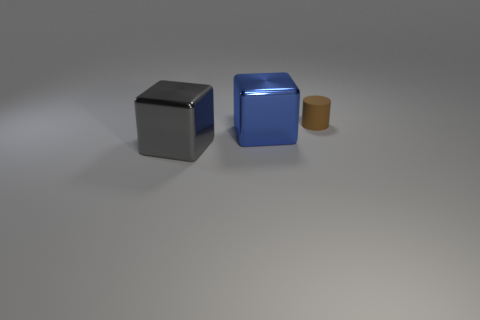What color is the large thing to the left of the cube that is behind the shiny block that is on the left side of the large blue object?
Provide a short and direct response. Gray. There is a gray object; is its size the same as the shiny cube right of the gray cube?
Offer a very short reply. Yes. How many things are either large metallic objects that are on the left side of the blue metal cube or shiny things that are to the left of the blue metal block?
Offer a very short reply. 1. There is a shiny object that is the same size as the gray metallic cube; what is its shape?
Ensure brevity in your answer.  Cube. The small brown rubber object that is behind the big metal object that is in front of the block behind the big gray metal cube is what shape?
Your answer should be very brief. Cylinder. Are there the same number of gray cubes that are behind the gray cube and big blue blocks?
Your answer should be very brief. No. Do the gray object and the blue metal thing have the same size?
Your answer should be compact. Yes. What number of metallic things are small gray cubes or blue objects?
Your answer should be compact. 1. There is a blue thing that is the same size as the gray shiny cube; what material is it?
Your answer should be very brief. Metal. How many other objects are there of the same material as the large blue object?
Make the answer very short. 1. 